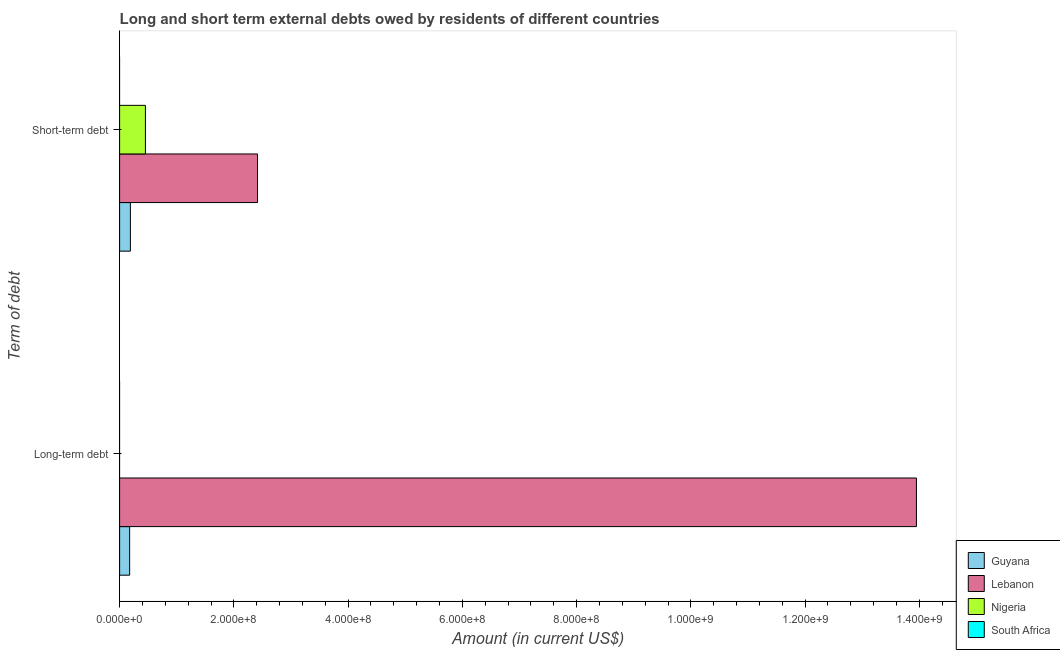How many bars are there on the 1st tick from the top?
Offer a terse response. 3. What is the label of the 2nd group of bars from the top?
Your response must be concise. Long-term debt. Across all countries, what is the maximum long-term debts owed by residents?
Provide a succinct answer. 1.39e+09. Across all countries, what is the minimum short-term debts owed by residents?
Provide a short and direct response. 0. In which country was the short-term debts owed by residents maximum?
Offer a terse response. Lebanon. What is the total short-term debts owed by residents in the graph?
Provide a short and direct response. 3.05e+08. What is the difference between the short-term debts owed by residents in Lebanon and that in Guyana?
Provide a short and direct response. 2.23e+08. What is the difference between the short-term debts owed by residents in Nigeria and the long-term debts owed by residents in Guyana?
Give a very brief answer. 2.76e+07. What is the average long-term debts owed by residents per country?
Make the answer very short. 3.53e+08. What is the difference between the short-term debts owed by residents and long-term debts owed by residents in Lebanon?
Offer a very short reply. -1.15e+09. What is the ratio of the short-term debts owed by residents in Lebanon to that in Guyana?
Make the answer very short. 12.79. In how many countries, is the short-term debts owed by residents greater than the average short-term debts owed by residents taken over all countries?
Your answer should be very brief. 1. Are the values on the major ticks of X-axis written in scientific E-notation?
Ensure brevity in your answer.  Yes. Does the graph contain any zero values?
Make the answer very short. Yes. Does the graph contain grids?
Ensure brevity in your answer.  No. Where does the legend appear in the graph?
Make the answer very short. Bottom right. How many legend labels are there?
Keep it short and to the point. 4. What is the title of the graph?
Your response must be concise. Long and short term external debts owed by residents of different countries. Does "Cambodia" appear as one of the legend labels in the graph?
Your answer should be compact. No. What is the label or title of the Y-axis?
Keep it short and to the point. Term of debt. What is the Amount (in current US$) in Guyana in Long-term debt?
Keep it short and to the point. 1.76e+07. What is the Amount (in current US$) in Lebanon in Long-term debt?
Provide a short and direct response. 1.39e+09. What is the Amount (in current US$) of Nigeria in Long-term debt?
Ensure brevity in your answer.  0. What is the Amount (in current US$) in South Africa in Long-term debt?
Provide a succinct answer. 0. What is the Amount (in current US$) of Guyana in Short-term debt?
Your response must be concise. 1.89e+07. What is the Amount (in current US$) of Lebanon in Short-term debt?
Provide a succinct answer. 2.41e+08. What is the Amount (in current US$) of Nigeria in Short-term debt?
Keep it short and to the point. 4.52e+07. Across all Term of debt, what is the maximum Amount (in current US$) of Guyana?
Your answer should be compact. 1.89e+07. Across all Term of debt, what is the maximum Amount (in current US$) in Lebanon?
Offer a very short reply. 1.39e+09. Across all Term of debt, what is the maximum Amount (in current US$) of Nigeria?
Offer a very short reply. 4.52e+07. Across all Term of debt, what is the minimum Amount (in current US$) in Guyana?
Ensure brevity in your answer.  1.76e+07. Across all Term of debt, what is the minimum Amount (in current US$) in Lebanon?
Your response must be concise. 2.41e+08. What is the total Amount (in current US$) of Guyana in the graph?
Your answer should be very brief. 3.64e+07. What is the total Amount (in current US$) in Lebanon in the graph?
Your answer should be very brief. 1.64e+09. What is the total Amount (in current US$) in Nigeria in the graph?
Your answer should be very brief. 4.52e+07. What is the total Amount (in current US$) of South Africa in the graph?
Your response must be concise. 0. What is the difference between the Amount (in current US$) in Guyana in Long-term debt and that in Short-term debt?
Keep it short and to the point. -1.31e+06. What is the difference between the Amount (in current US$) of Lebanon in Long-term debt and that in Short-term debt?
Offer a very short reply. 1.15e+09. What is the difference between the Amount (in current US$) in Guyana in Long-term debt and the Amount (in current US$) in Lebanon in Short-term debt?
Provide a short and direct response. -2.24e+08. What is the difference between the Amount (in current US$) of Guyana in Long-term debt and the Amount (in current US$) of Nigeria in Short-term debt?
Your answer should be very brief. -2.76e+07. What is the difference between the Amount (in current US$) in Lebanon in Long-term debt and the Amount (in current US$) in Nigeria in Short-term debt?
Offer a terse response. 1.35e+09. What is the average Amount (in current US$) in Guyana per Term of debt?
Make the answer very short. 1.82e+07. What is the average Amount (in current US$) of Lebanon per Term of debt?
Provide a short and direct response. 8.18e+08. What is the average Amount (in current US$) in Nigeria per Term of debt?
Your answer should be compact. 2.26e+07. What is the difference between the Amount (in current US$) in Guyana and Amount (in current US$) in Lebanon in Long-term debt?
Provide a short and direct response. -1.38e+09. What is the difference between the Amount (in current US$) in Guyana and Amount (in current US$) in Lebanon in Short-term debt?
Your answer should be very brief. -2.23e+08. What is the difference between the Amount (in current US$) of Guyana and Amount (in current US$) of Nigeria in Short-term debt?
Your answer should be compact. -2.63e+07. What is the difference between the Amount (in current US$) in Lebanon and Amount (in current US$) in Nigeria in Short-term debt?
Make the answer very short. 1.96e+08. What is the ratio of the Amount (in current US$) in Guyana in Long-term debt to that in Short-term debt?
Your response must be concise. 0.93. What is the ratio of the Amount (in current US$) of Lebanon in Long-term debt to that in Short-term debt?
Your response must be concise. 5.78. What is the difference between the highest and the second highest Amount (in current US$) in Guyana?
Your answer should be compact. 1.31e+06. What is the difference between the highest and the second highest Amount (in current US$) in Lebanon?
Provide a succinct answer. 1.15e+09. What is the difference between the highest and the lowest Amount (in current US$) in Guyana?
Give a very brief answer. 1.31e+06. What is the difference between the highest and the lowest Amount (in current US$) of Lebanon?
Keep it short and to the point. 1.15e+09. What is the difference between the highest and the lowest Amount (in current US$) in Nigeria?
Ensure brevity in your answer.  4.52e+07. 